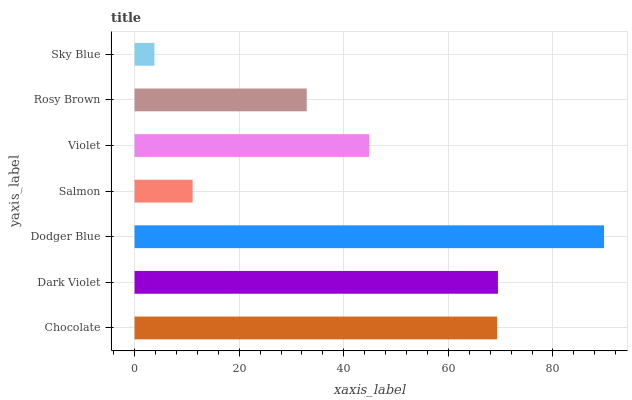Is Sky Blue the minimum?
Answer yes or no. Yes. Is Dodger Blue the maximum?
Answer yes or no. Yes. Is Dark Violet the minimum?
Answer yes or no. No. Is Dark Violet the maximum?
Answer yes or no. No. Is Dark Violet greater than Chocolate?
Answer yes or no. Yes. Is Chocolate less than Dark Violet?
Answer yes or no. Yes. Is Chocolate greater than Dark Violet?
Answer yes or no. No. Is Dark Violet less than Chocolate?
Answer yes or no. No. Is Violet the high median?
Answer yes or no. Yes. Is Violet the low median?
Answer yes or no. Yes. Is Salmon the high median?
Answer yes or no. No. Is Dodger Blue the low median?
Answer yes or no. No. 